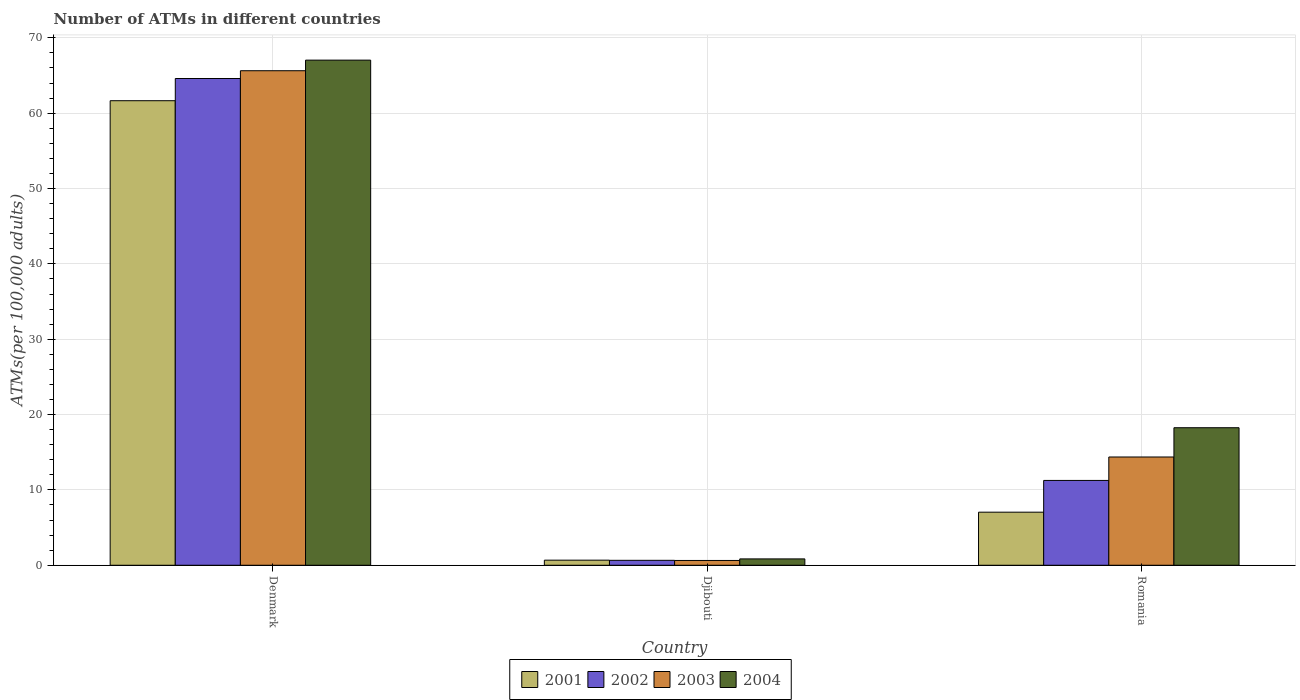How many different coloured bars are there?
Your response must be concise. 4. How many groups of bars are there?
Offer a terse response. 3. Are the number of bars per tick equal to the number of legend labels?
Your answer should be compact. Yes. What is the label of the 1st group of bars from the left?
Provide a succinct answer. Denmark. In how many cases, is the number of bars for a given country not equal to the number of legend labels?
Offer a very short reply. 0. What is the number of ATMs in 2001 in Romania?
Keep it short and to the point. 7.04. Across all countries, what is the maximum number of ATMs in 2001?
Give a very brief answer. 61.66. Across all countries, what is the minimum number of ATMs in 2001?
Offer a terse response. 0.68. In which country was the number of ATMs in 2003 minimum?
Give a very brief answer. Djibouti. What is the total number of ATMs in 2004 in the graph?
Provide a short and direct response. 86.14. What is the difference between the number of ATMs in 2004 in Djibouti and that in Romania?
Provide a succinct answer. -17.41. What is the difference between the number of ATMs in 2003 in Djibouti and the number of ATMs in 2004 in Denmark?
Make the answer very short. -66.41. What is the average number of ATMs in 2004 per country?
Your answer should be very brief. 28.71. What is the difference between the number of ATMs of/in 2003 and number of ATMs of/in 2002 in Djibouti?
Your answer should be compact. -0.02. In how many countries, is the number of ATMs in 2002 greater than 6?
Provide a succinct answer. 2. What is the ratio of the number of ATMs in 2001 in Denmark to that in Romania?
Offer a very short reply. 8.75. Is the difference between the number of ATMs in 2003 in Djibouti and Romania greater than the difference between the number of ATMs in 2002 in Djibouti and Romania?
Give a very brief answer. No. What is the difference between the highest and the second highest number of ATMs in 2001?
Ensure brevity in your answer.  -60.98. What is the difference between the highest and the lowest number of ATMs in 2004?
Your response must be concise. 66.2. In how many countries, is the number of ATMs in 2001 greater than the average number of ATMs in 2001 taken over all countries?
Your answer should be very brief. 1. Is the sum of the number of ATMs in 2004 in Denmark and Djibouti greater than the maximum number of ATMs in 2003 across all countries?
Offer a terse response. Yes. What does the 1st bar from the right in Denmark represents?
Keep it short and to the point. 2004. How many bars are there?
Offer a terse response. 12. Are all the bars in the graph horizontal?
Provide a succinct answer. No. How many countries are there in the graph?
Your answer should be compact. 3. Are the values on the major ticks of Y-axis written in scientific E-notation?
Your answer should be compact. No. Does the graph contain grids?
Make the answer very short. Yes. How many legend labels are there?
Offer a terse response. 4. How are the legend labels stacked?
Keep it short and to the point. Horizontal. What is the title of the graph?
Your answer should be very brief. Number of ATMs in different countries. What is the label or title of the X-axis?
Your response must be concise. Country. What is the label or title of the Y-axis?
Offer a terse response. ATMs(per 100,0 adults). What is the ATMs(per 100,000 adults) in 2001 in Denmark?
Give a very brief answer. 61.66. What is the ATMs(per 100,000 adults) of 2002 in Denmark?
Your response must be concise. 64.61. What is the ATMs(per 100,000 adults) of 2003 in Denmark?
Provide a short and direct response. 65.64. What is the ATMs(per 100,000 adults) in 2004 in Denmark?
Your response must be concise. 67.04. What is the ATMs(per 100,000 adults) in 2001 in Djibouti?
Provide a succinct answer. 0.68. What is the ATMs(per 100,000 adults) in 2002 in Djibouti?
Make the answer very short. 0.66. What is the ATMs(per 100,000 adults) in 2003 in Djibouti?
Give a very brief answer. 0.64. What is the ATMs(per 100,000 adults) of 2004 in Djibouti?
Your response must be concise. 0.84. What is the ATMs(per 100,000 adults) of 2001 in Romania?
Give a very brief answer. 7.04. What is the ATMs(per 100,000 adults) of 2002 in Romania?
Give a very brief answer. 11.26. What is the ATMs(per 100,000 adults) in 2003 in Romania?
Ensure brevity in your answer.  14.37. What is the ATMs(per 100,000 adults) of 2004 in Romania?
Offer a very short reply. 18.26. Across all countries, what is the maximum ATMs(per 100,000 adults) in 2001?
Your answer should be compact. 61.66. Across all countries, what is the maximum ATMs(per 100,000 adults) in 2002?
Ensure brevity in your answer.  64.61. Across all countries, what is the maximum ATMs(per 100,000 adults) of 2003?
Make the answer very short. 65.64. Across all countries, what is the maximum ATMs(per 100,000 adults) in 2004?
Ensure brevity in your answer.  67.04. Across all countries, what is the minimum ATMs(per 100,000 adults) of 2001?
Provide a short and direct response. 0.68. Across all countries, what is the minimum ATMs(per 100,000 adults) in 2002?
Offer a terse response. 0.66. Across all countries, what is the minimum ATMs(per 100,000 adults) of 2003?
Offer a very short reply. 0.64. Across all countries, what is the minimum ATMs(per 100,000 adults) of 2004?
Provide a short and direct response. 0.84. What is the total ATMs(per 100,000 adults) in 2001 in the graph?
Provide a succinct answer. 69.38. What is the total ATMs(per 100,000 adults) in 2002 in the graph?
Make the answer very short. 76.52. What is the total ATMs(per 100,000 adults) in 2003 in the graph?
Provide a succinct answer. 80.65. What is the total ATMs(per 100,000 adults) of 2004 in the graph?
Provide a short and direct response. 86.14. What is the difference between the ATMs(per 100,000 adults) of 2001 in Denmark and that in Djibouti?
Make the answer very short. 60.98. What is the difference between the ATMs(per 100,000 adults) in 2002 in Denmark and that in Djibouti?
Provide a succinct answer. 63.95. What is the difference between the ATMs(per 100,000 adults) in 2003 in Denmark and that in Djibouti?
Offer a very short reply. 65. What is the difference between the ATMs(per 100,000 adults) in 2004 in Denmark and that in Djibouti?
Ensure brevity in your answer.  66.2. What is the difference between the ATMs(per 100,000 adults) in 2001 in Denmark and that in Romania?
Offer a very short reply. 54.61. What is the difference between the ATMs(per 100,000 adults) in 2002 in Denmark and that in Romania?
Ensure brevity in your answer.  53.35. What is the difference between the ATMs(per 100,000 adults) of 2003 in Denmark and that in Romania?
Give a very brief answer. 51.27. What is the difference between the ATMs(per 100,000 adults) in 2004 in Denmark and that in Romania?
Give a very brief answer. 48.79. What is the difference between the ATMs(per 100,000 adults) of 2001 in Djibouti and that in Romania?
Make the answer very short. -6.37. What is the difference between the ATMs(per 100,000 adults) of 2002 in Djibouti and that in Romania?
Make the answer very short. -10.6. What is the difference between the ATMs(per 100,000 adults) in 2003 in Djibouti and that in Romania?
Your answer should be very brief. -13.73. What is the difference between the ATMs(per 100,000 adults) of 2004 in Djibouti and that in Romania?
Offer a very short reply. -17.41. What is the difference between the ATMs(per 100,000 adults) of 2001 in Denmark and the ATMs(per 100,000 adults) of 2002 in Djibouti?
Your answer should be compact. 61. What is the difference between the ATMs(per 100,000 adults) in 2001 in Denmark and the ATMs(per 100,000 adults) in 2003 in Djibouti?
Make the answer very short. 61.02. What is the difference between the ATMs(per 100,000 adults) of 2001 in Denmark and the ATMs(per 100,000 adults) of 2004 in Djibouti?
Provide a succinct answer. 60.81. What is the difference between the ATMs(per 100,000 adults) in 2002 in Denmark and the ATMs(per 100,000 adults) in 2003 in Djibouti?
Provide a succinct answer. 63.97. What is the difference between the ATMs(per 100,000 adults) in 2002 in Denmark and the ATMs(per 100,000 adults) in 2004 in Djibouti?
Your response must be concise. 63.76. What is the difference between the ATMs(per 100,000 adults) of 2003 in Denmark and the ATMs(per 100,000 adults) of 2004 in Djibouti?
Keep it short and to the point. 64.79. What is the difference between the ATMs(per 100,000 adults) in 2001 in Denmark and the ATMs(per 100,000 adults) in 2002 in Romania?
Provide a short and direct response. 50.4. What is the difference between the ATMs(per 100,000 adults) of 2001 in Denmark and the ATMs(per 100,000 adults) of 2003 in Romania?
Offer a terse response. 47.29. What is the difference between the ATMs(per 100,000 adults) of 2001 in Denmark and the ATMs(per 100,000 adults) of 2004 in Romania?
Your response must be concise. 43.4. What is the difference between the ATMs(per 100,000 adults) in 2002 in Denmark and the ATMs(per 100,000 adults) in 2003 in Romania?
Your answer should be very brief. 50.24. What is the difference between the ATMs(per 100,000 adults) in 2002 in Denmark and the ATMs(per 100,000 adults) in 2004 in Romania?
Offer a terse response. 46.35. What is the difference between the ATMs(per 100,000 adults) of 2003 in Denmark and the ATMs(per 100,000 adults) of 2004 in Romania?
Your response must be concise. 47.38. What is the difference between the ATMs(per 100,000 adults) of 2001 in Djibouti and the ATMs(per 100,000 adults) of 2002 in Romania?
Your answer should be very brief. -10.58. What is the difference between the ATMs(per 100,000 adults) of 2001 in Djibouti and the ATMs(per 100,000 adults) of 2003 in Romania?
Offer a very short reply. -13.69. What is the difference between the ATMs(per 100,000 adults) in 2001 in Djibouti and the ATMs(per 100,000 adults) in 2004 in Romania?
Provide a short and direct response. -17.58. What is the difference between the ATMs(per 100,000 adults) in 2002 in Djibouti and the ATMs(per 100,000 adults) in 2003 in Romania?
Your answer should be compact. -13.71. What is the difference between the ATMs(per 100,000 adults) of 2002 in Djibouti and the ATMs(per 100,000 adults) of 2004 in Romania?
Offer a very short reply. -17.6. What is the difference between the ATMs(per 100,000 adults) of 2003 in Djibouti and the ATMs(per 100,000 adults) of 2004 in Romania?
Offer a terse response. -17.62. What is the average ATMs(per 100,000 adults) of 2001 per country?
Give a very brief answer. 23.13. What is the average ATMs(per 100,000 adults) in 2002 per country?
Keep it short and to the point. 25.51. What is the average ATMs(per 100,000 adults) of 2003 per country?
Your answer should be compact. 26.88. What is the average ATMs(per 100,000 adults) of 2004 per country?
Give a very brief answer. 28.71. What is the difference between the ATMs(per 100,000 adults) in 2001 and ATMs(per 100,000 adults) in 2002 in Denmark?
Provide a succinct answer. -2.95. What is the difference between the ATMs(per 100,000 adults) of 2001 and ATMs(per 100,000 adults) of 2003 in Denmark?
Keep it short and to the point. -3.98. What is the difference between the ATMs(per 100,000 adults) in 2001 and ATMs(per 100,000 adults) in 2004 in Denmark?
Give a very brief answer. -5.39. What is the difference between the ATMs(per 100,000 adults) in 2002 and ATMs(per 100,000 adults) in 2003 in Denmark?
Ensure brevity in your answer.  -1.03. What is the difference between the ATMs(per 100,000 adults) of 2002 and ATMs(per 100,000 adults) of 2004 in Denmark?
Your answer should be very brief. -2.44. What is the difference between the ATMs(per 100,000 adults) of 2003 and ATMs(per 100,000 adults) of 2004 in Denmark?
Ensure brevity in your answer.  -1.41. What is the difference between the ATMs(per 100,000 adults) in 2001 and ATMs(per 100,000 adults) in 2002 in Djibouti?
Keep it short and to the point. 0.02. What is the difference between the ATMs(per 100,000 adults) in 2001 and ATMs(per 100,000 adults) in 2003 in Djibouti?
Your answer should be compact. 0.04. What is the difference between the ATMs(per 100,000 adults) in 2001 and ATMs(per 100,000 adults) in 2004 in Djibouti?
Ensure brevity in your answer.  -0.17. What is the difference between the ATMs(per 100,000 adults) of 2002 and ATMs(per 100,000 adults) of 2003 in Djibouti?
Offer a terse response. 0.02. What is the difference between the ATMs(per 100,000 adults) of 2002 and ATMs(per 100,000 adults) of 2004 in Djibouti?
Keep it short and to the point. -0.19. What is the difference between the ATMs(per 100,000 adults) in 2003 and ATMs(per 100,000 adults) in 2004 in Djibouti?
Provide a succinct answer. -0.21. What is the difference between the ATMs(per 100,000 adults) of 2001 and ATMs(per 100,000 adults) of 2002 in Romania?
Your answer should be very brief. -4.21. What is the difference between the ATMs(per 100,000 adults) of 2001 and ATMs(per 100,000 adults) of 2003 in Romania?
Offer a terse response. -7.32. What is the difference between the ATMs(per 100,000 adults) of 2001 and ATMs(per 100,000 adults) of 2004 in Romania?
Offer a very short reply. -11.21. What is the difference between the ATMs(per 100,000 adults) in 2002 and ATMs(per 100,000 adults) in 2003 in Romania?
Your response must be concise. -3.11. What is the difference between the ATMs(per 100,000 adults) of 2002 and ATMs(per 100,000 adults) of 2004 in Romania?
Provide a short and direct response. -7. What is the difference between the ATMs(per 100,000 adults) of 2003 and ATMs(per 100,000 adults) of 2004 in Romania?
Ensure brevity in your answer.  -3.89. What is the ratio of the ATMs(per 100,000 adults) of 2001 in Denmark to that in Djibouti?
Offer a terse response. 91.18. What is the ratio of the ATMs(per 100,000 adults) of 2002 in Denmark to that in Djibouti?
Ensure brevity in your answer.  98.45. What is the ratio of the ATMs(per 100,000 adults) of 2003 in Denmark to that in Djibouti?
Provide a short and direct response. 102.88. What is the ratio of the ATMs(per 100,000 adults) of 2004 in Denmark to that in Djibouti?
Provide a short and direct response. 79.46. What is the ratio of the ATMs(per 100,000 adults) in 2001 in Denmark to that in Romania?
Make the answer very short. 8.75. What is the ratio of the ATMs(per 100,000 adults) in 2002 in Denmark to that in Romania?
Your response must be concise. 5.74. What is the ratio of the ATMs(per 100,000 adults) in 2003 in Denmark to that in Romania?
Your answer should be compact. 4.57. What is the ratio of the ATMs(per 100,000 adults) of 2004 in Denmark to that in Romania?
Keep it short and to the point. 3.67. What is the ratio of the ATMs(per 100,000 adults) in 2001 in Djibouti to that in Romania?
Give a very brief answer. 0.1. What is the ratio of the ATMs(per 100,000 adults) in 2002 in Djibouti to that in Romania?
Offer a terse response. 0.06. What is the ratio of the ATMs(per 100,000 adults) in 2003 in Djibouti to that in Romania?
Give a very brief answer. 0.04. What is the ratio of the ATMs(per 100,000 adults) in 2004 in Djibouti to that in Romania?
Provide a short and direct response. 0.05. What is the difference between the highest and the second highest ATMs(per 100,000 adults) of 2001?
Your answer should be very brief. 54.61. What is the difference between the highest and the second highest ATMs(per 100,000 adults) of 2002?
Make the answer very short. 53.35. What is the difference between the highest and the second highest ATMs(per 100,000 adults) of 2003?
Provide a short and direct response. 51.27. What is the difference between the highest and the second highest ATMs(per 100,000 adults) in 2004?
Offer a terse response. 48.79. What is the difference between the highest and the lowest ATMs(per 100,000 adults) of 2001?
Offer a very short reply. 60.98. What is the difference between the highest and the lowest ATMs(per 100,000 adults) in 2002?
Provide a succinct answer. 63.95. What is the difference between the highest and the lowest ATMs(per 100,000 adults) in 2003?
Offer a terse response. 65. What is the difference between the highest and the lowest ATMs(per 100,000 adults) in 2004?
Ensure brevity in your answer.  66.2. 